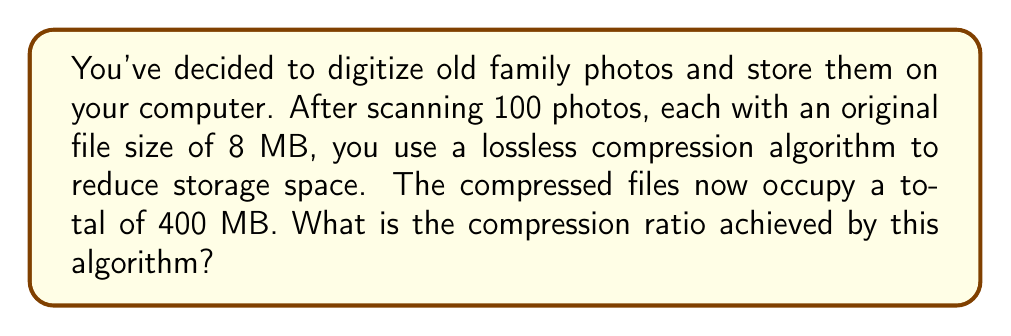Can you solve this math problem? To solve this problem, let's follow these steps:

1. Calculate the total size of the original files:
   $$\text{Original size} = 100 \text{ photos} \times 8 \text{ MB} = 800 \text{ MB}$$

2. We're given that the compressed size is 400 MB.

3. The compression ratio is defined as:
   $$\text{Compression ratio} = \frac{\text{Original size}}{\text{Compressed size}}$$

4. Substituting the values:
   $$\text{Compression ratio} = \frac{800 \text{ MB}}{400 \text{ MB}} = 2$$

5. This can be expressed as 2:1, meaning the original data has been compressed to half its original size.

6. To convert this to a percentage of space saved:
   $$\text{Space saved} = \left(1 - \frac{1}{\text{Compression ratio}}\right) \times 100\%$$
   $$= \left(1 - \frac{1}{2}\right) \times 100\% = 50\%$$

Thus, the lossless compression algorithm has achieved a compression ratio of 2:1, saving 50% of the original storage space.
Answer: The compression ratio achieved by the algorithm is 2:1 or 2. 